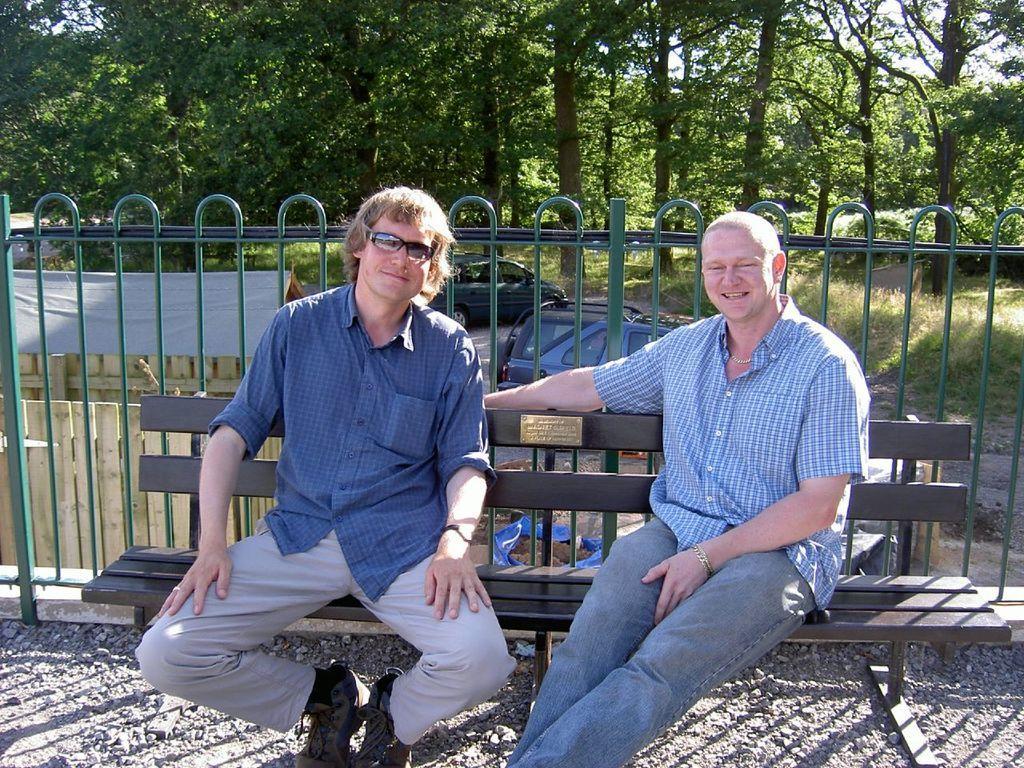Could you give a brief overview of what you see in this image? In this image we can see there are people sitting on the bench and there is a fence at the back. And there are vehicles on the ground. There are trees, shed, sticks and cover. 